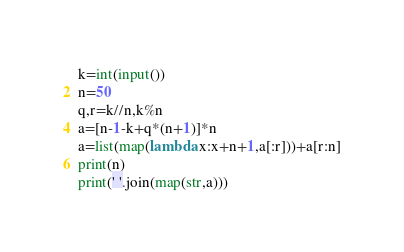<code> <loc_0><loc_0><loc_500><loc_500><_Python_>k=int(input())
n=50
q,r=k//n,k%n
a=[n-1-k+q*(n+1)]*n
a=list(map(lambda x:x+n+1,a[:r]))+a[r:n]
print(n)
print(' '.join(map(str,a)))</code> 